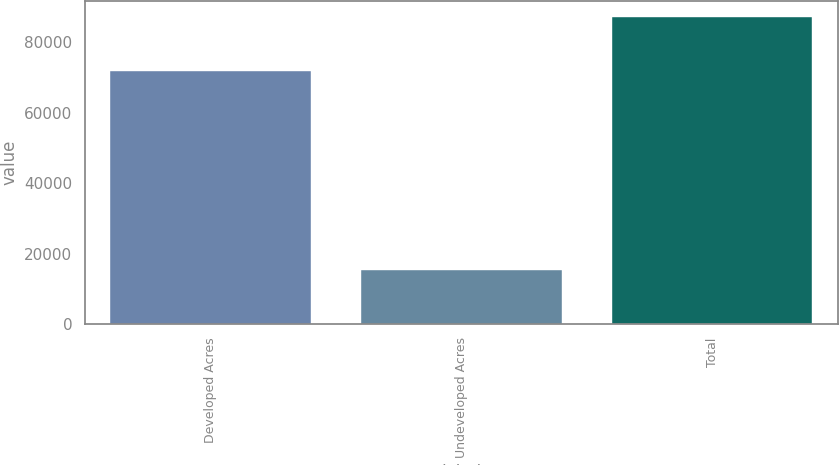Convert chart to OTSL. <chart><loc_0><loc_0><loc_500><loc_500><bar_chart><fcel>Developed Acres<fcel>Undeveloped Acres<fcel>Total<nl><fcel>71919<fcel>15369<fcel>87288<nl></chart> 